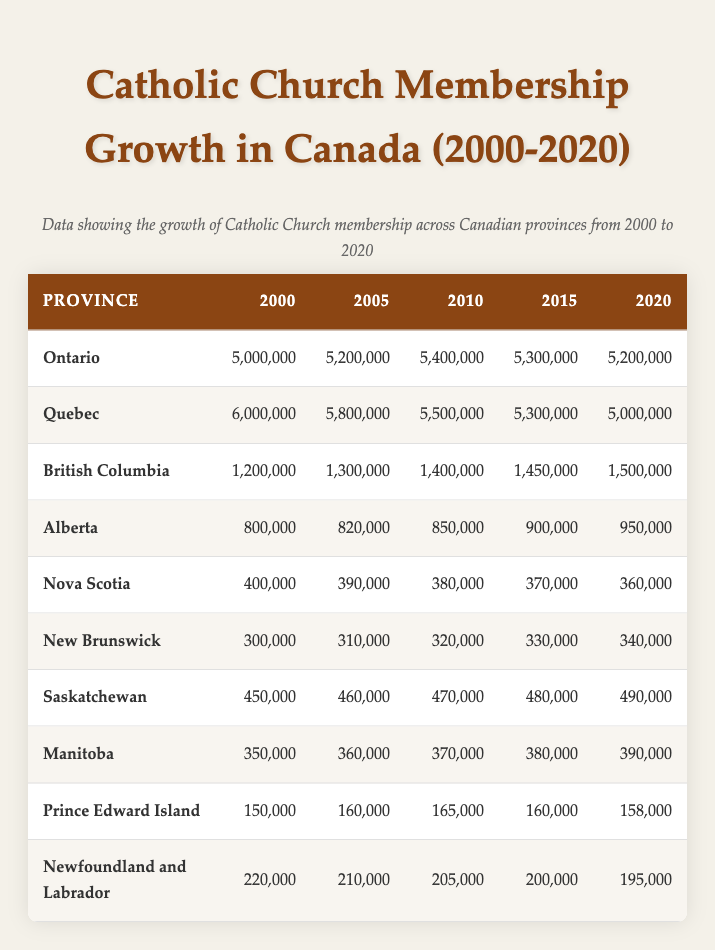What was the Catholic Church membership in Quebec in 2000? According to the table, the membership count for Quebec in 2000 is directly provided as 6,000,000.
Answer: 6,000,000 How much did the Catholic Church membership in Alberta grow from 2000 to 2010? The membership in Alberta in 2000 was 800,000, and in 2010 it was 850,000. The growth can be calculated as 850,000 - 800,000 = 50,000.
Answer: 50,000 What was the total Catholic Church membership in Canada for the year 2005? To find the total for 2005, we sum the memberships of all provinces for that year: 5,200,000 + 5,800,000 + 1,300,000 + 820,000 + 390,000 + 310,000 + 460,000 + 360,000 + 160,000 + 210,000 = 15,820,000.
Answer: 15,820,000 Is it true that Nova Scotia's Catholic Church membership decreased from 2005 to 2020? The membership in Nova Scotia for 2005 is 390,000 and for 2020 it is 360,000. Since 360,000 is less than 390,000, the statement is true.
Answer: True Which province had the highest Catholic Church membership in 2015? By comparing the values for 2015, Ontario has 5,300,000, Quebec has 5,300,000, British Columbia has 1,450,000, Alberta has 900,000, and so on. Both Ontario and Quebec share the highest membership of 5,300,000 in 2015.
Answer: Ontario and Quebec What is the average Catholic Church membership in British Columbia from 2000 to 2020? The values for British Columbia over the years are: 1,200,000 (2000), 1,300,000 (2005), 1,400,000 (2010), 1,450,000 (2015), and 1,500,000 (2020). Summing these gives 1,200,000 + 1,300,000 + 1,400,000 + 1,450,000 + 1,500,000 = 6,850,000; dividing by 5 gives an average of 6,850,000 / 5 = 1,370,000.
Answer: 1,370,000 Did the Catholic Church membership in Newfoundland and Labrador decline consistently from 2000 to 2020? The values for each year are: 220,000 (2000), 210,000 (2005), 205,000 (2010), 200,000 (2015), and 195,000 (2020). Each subsequent year shows a decrease, thus membership declined consistently over this period.
Answer: Yes How many provinces had a Catholic Church membership of over 1,000,000 in 2020? The provinces with memberships over 1,000,000 in 2020 are Ontario (5,200,000), Quebec (5,000,000), British Columbia (1,500,000), and Alberta (950,000). So we count Ontario, Quebec, and British Columbia. Hence, three provinces had memberships over 1,000,000.
Answer: 3 